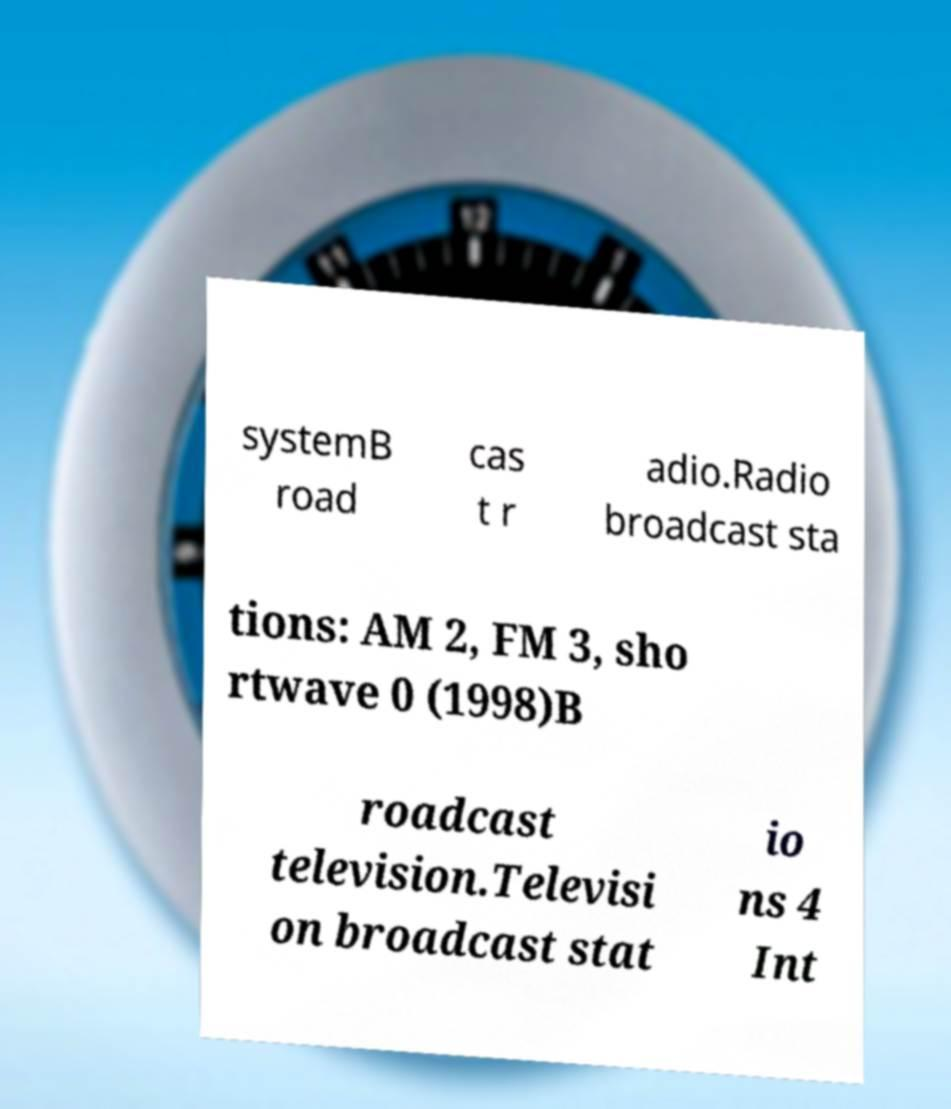Could you assist in decoding the text presented in this image and type it out clearly? systemB road cas t r adio.Radio broadcast sta tions: AM 2, FM 3, sho rtwave 0 (1998)B roadcast television.Televisi on broadcast stat io ns 4 Int 